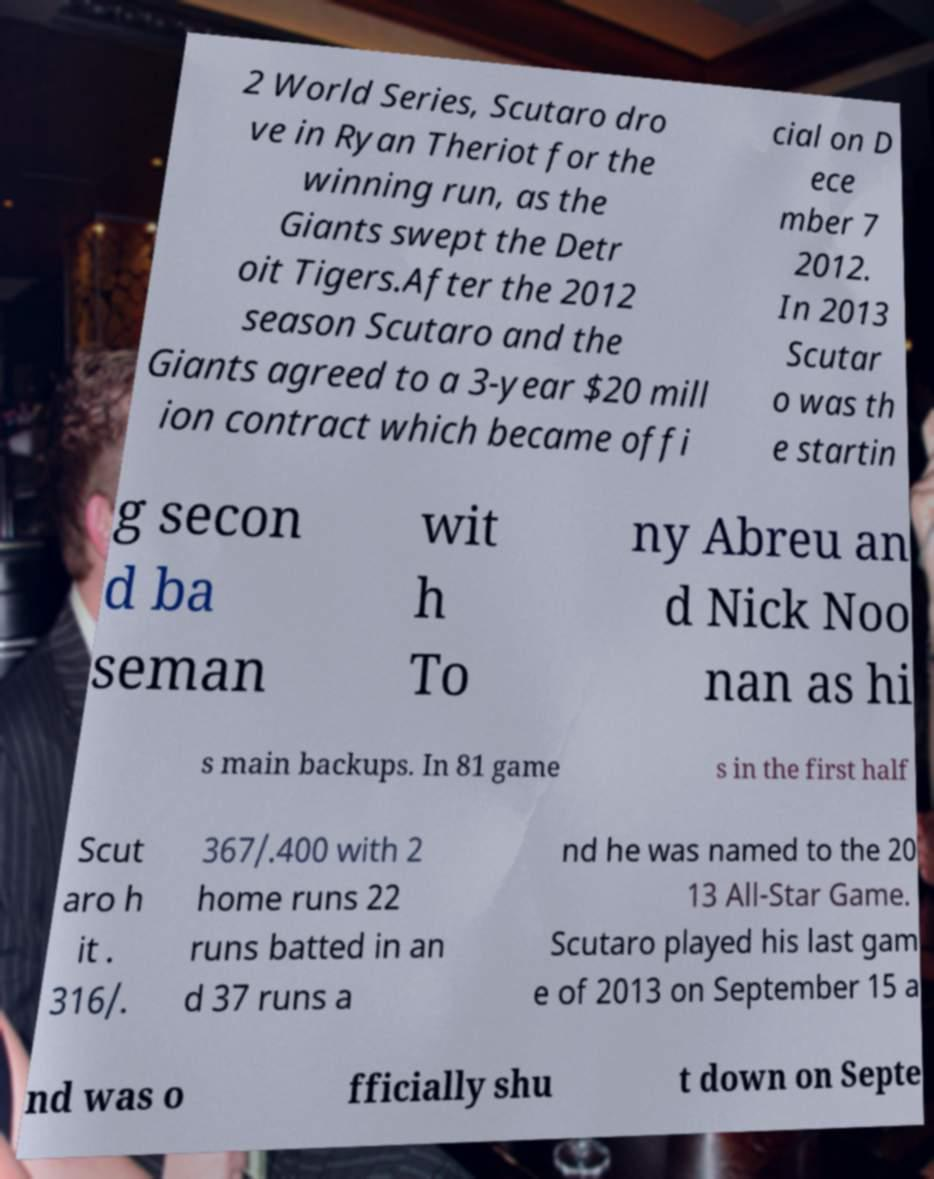What messages or text are displayed in this image? I need them in a readable, typed format. 2 World Series, Scutaro dro ve in Ryan Theriot for the winning run, as the Giants swept the Detr oit Tigers.After the 2012 season Scutaro and the Giants agreed to a 3-year $20 mill ion contract which became offi cial on D ece mber 7 2012. In 2013 Scutar o was th e startin g secon d ba seman wit h To ny Abreu an d Nick Noo nan as hi s main backups. In 81 game s in the first half Scut aro h it . 316/. 367/.400 with 2 home runs 22 runs batted in an d 37 runs a nd he was named to the 20 13 All-Star Game. Scutaro played his last gam e of 2013 on September 15 a nd was o fficially shu t down on Septe 